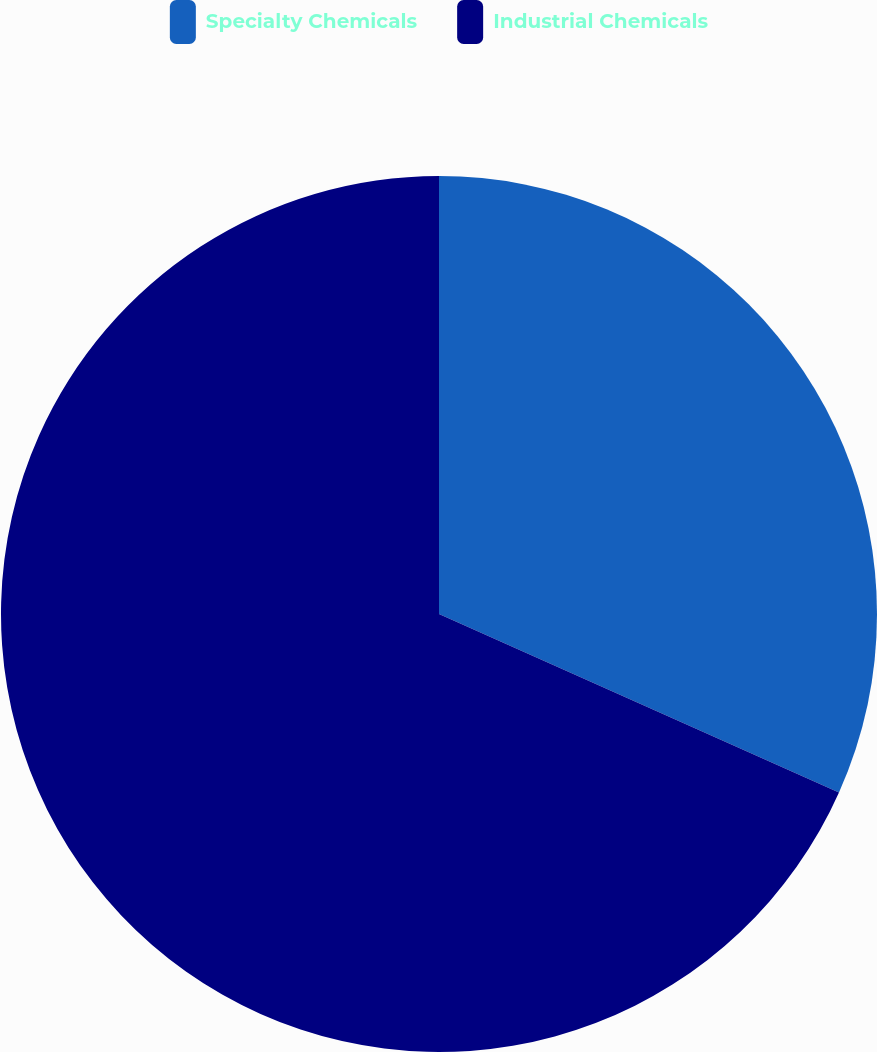Convert chart to OTSL. <chart><loc_0><loc_0><loc_500><loc_500><pie_chart><fcel>Specialty Chemicals<fcel>Industrial Chemicals<nl><fcel>31.68%<fcel>68.32%<nl></chart> 